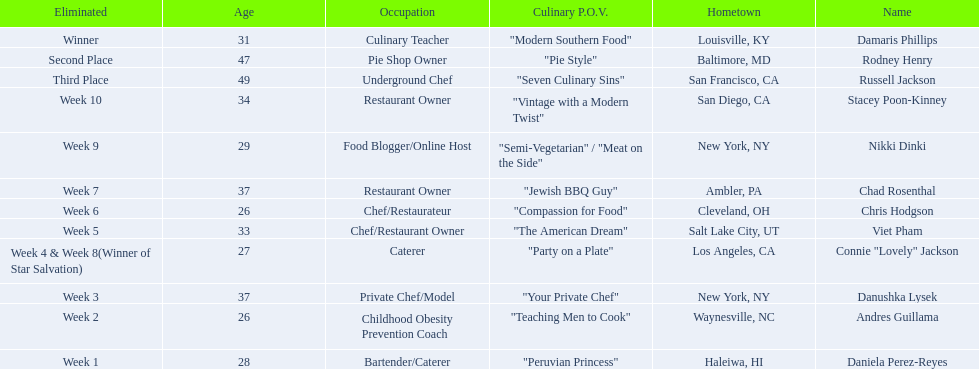Who was eliminated first, nikki dinki or viet pham? Viet Pham. 